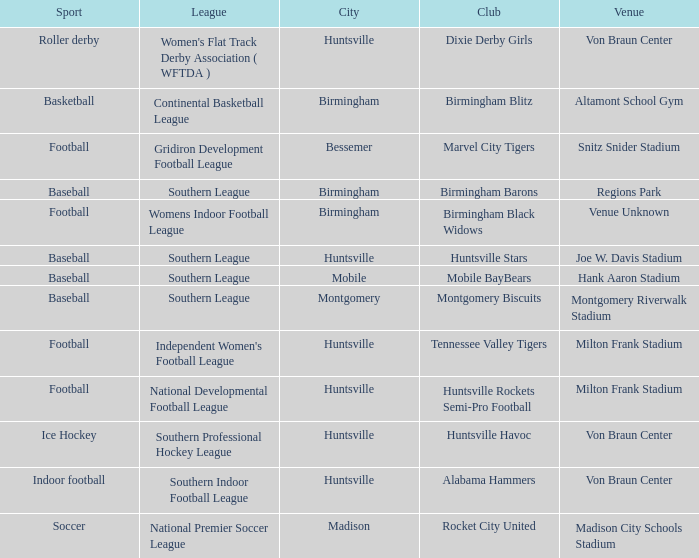Which venue held a basketball team? Altamont School Gym. Parse the table in full. {'header': ['Sport', 'League', 'City', 'Club', 'Venue'], 'rows': [['Roller derby', "Women's Flat Track Derby Association ( WFTDA )", 'Huntsville', 'Dixie Derby Girls', 'Von Braun Center'], ['Basketball', 'Continental Basketball League', 'Birmingham', 'Birmingham Blitz', 'Altamont School Gym'], ['Football', 'Gridiron Development Football League', 'Bessemer', 'Marvel City Tigers', 'Snitz Snider Stadium'], ['Baseball', 'Southern League', 'Birmingham', 'Birmingham Barons', 'Regions Park'], ['Football', 'Womens Indoor Football League', 'Birmingham', 'Birmingham Black Widows', 'Venue Unknown'], ['Baseball', 'Southern League', 'Huntsville', 'Huntsville Stars', 'Joe W. Davis Stadium'], ['Baseball', 'Southern League', 'Mobile', 'Mobile BayBears', 'Hank Aaron Stadium'], ['Baseball', 'Southern League', 'Montgomery', 'Montgomery Biscuits', 'Montgomery Riverwalk Stadium'], ['Football', "Independent Women's Football League", 'Huntsville', 'Tennessee Valley Tigers', 'Milton Frank Stadium'], ['Football', 'National Developmental Football League', 'Huntsville', 'Huntsville Rockets Semi-Pro Football', 'Milton Frank Stadium'], ['Ice Hockey', 'Southern Professional Hockey League', 'Huntsville', 'Huntsville Havoc', 'Von Braun Center'], ['Indoor football', 'Southern Indoor Football League', 'Huntsville', 'Alabama Hammers', 'Von Braun Center'], ['Soccer', 'National Premier Soccer League', 'Madison', 'Rocket City United', 'Madison City Schools Stadium']]} 